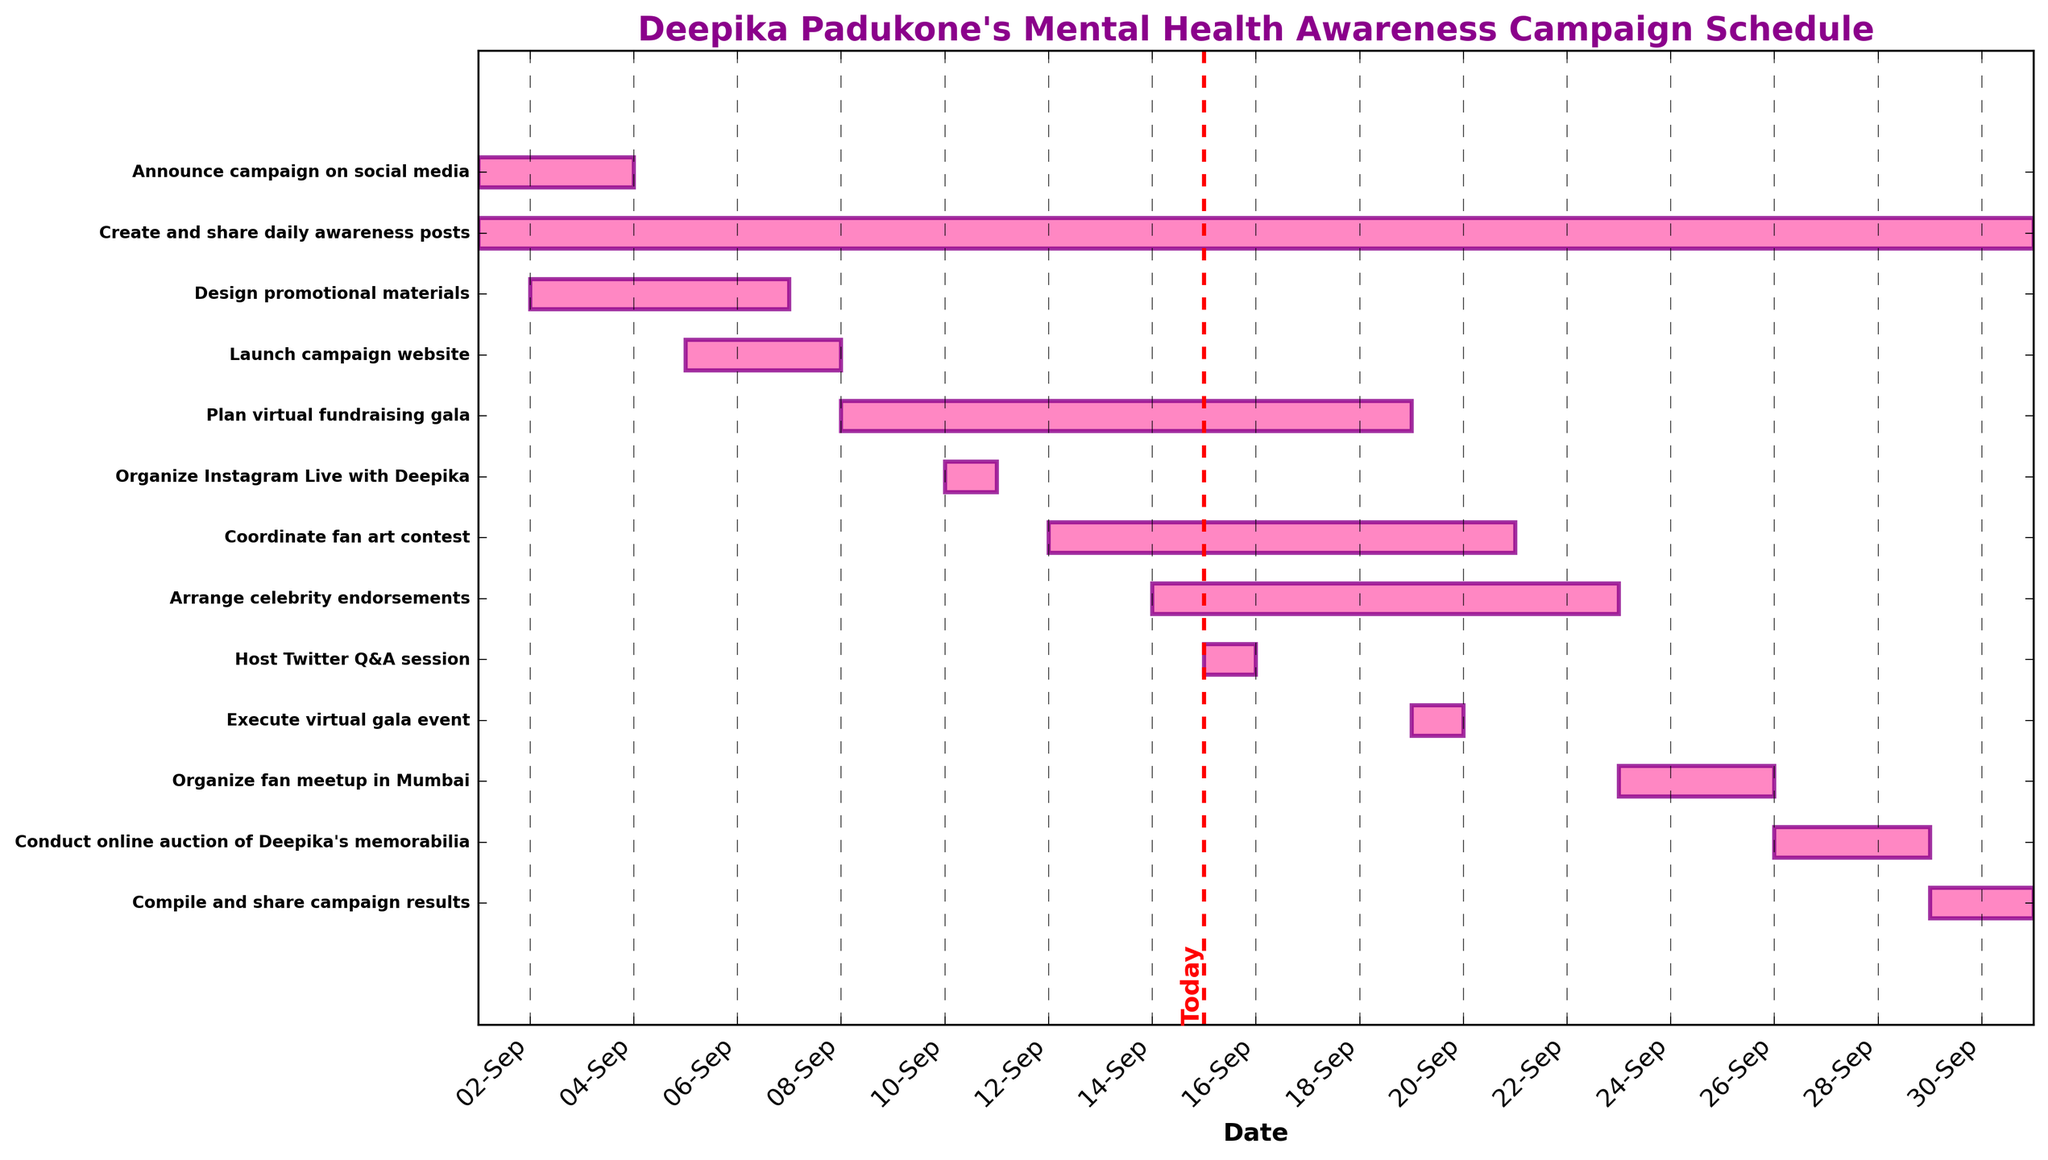When does the campaign start and end? The start date of the campaign is the first date listed on the x-axis, and the end date is the last date listed. The campaign starts on September 1st and ends on September 30th.
Answer: September 1st to September 30th Which task has the longest duration? To determine this, look at the length of the horizontal bars for each task in the Gantt chart. The task with the longest bar indicates the longest duration. "Create and share daily awareness posts" runs the entire length of the Gantt chart.
Answer: Create and share daily awareness posts Are there any tasks scheduled to occur on September 15th? Identify any bars that align with the vertical line marked for September 15th. "Host Twitter Q&A session" is scheduled for September 15th.
Answer: Host Twitter Q&A session How many days is the "Organize fan meetup in Mumbai" task scheduled for? Count the days covered by the horizontal bar for "Organize fan meetup in Mumbai." From September 23rd to September 25th is 3 days.
Answer: 3 days Which tasks are overlapping between September 12th and September 15th? Identify all bars that start or continue through the range of dates from September 12th to September 15th. Both "Coordinate fan art contest" and "Arrange celebrity endorsements" fall within this date range.
Answer: Coordinate fan art contest, Arrange celebrity endorsements Which task is scheduled to be executed on the same day as "Plan virtual fundraising gala"? Look for any other tasks that align on the same starting day as "Plan virtual fundraising gala," which starts on September 8th. No other tasks start on September 8th.
Answer: None What task ends just before the "Organize fan meetup in Mumbai" begins? Identify which task's end date is right before the start date of "Organize fan meetup in Mumbai," which starts on September 23rd. "Arrange celebrity endorsements" ends on September 22nd.
Answer: Arrange celebrity endorsements How long after the campaign launch is the "Organize Instagram Live with Deepika" scheduled? Calculate the difference in days between the end of the "Launch campaign website" on September 7th and the start of the "Organize Instagram Live with Deepika" on September 10th. There are 3 days between these events.
Answer: 3 days Which tasks run concurrently with the "Compile and share campaign results"? Identify tasks that overlap with the date range of "Compile and share campaign results," which is from September 29th to September 30th. "Create and share daily awareness posts" also runs during this date range.
Answer: Create and share daily awareness posts 